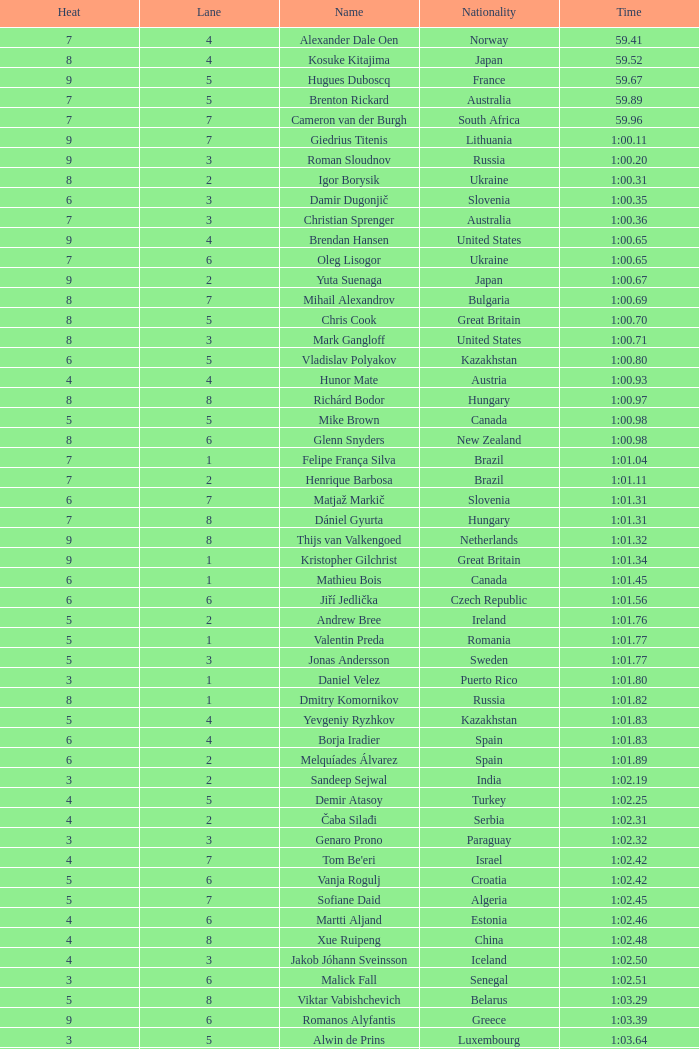What is the time in a heat smaller than 5, in Lane 5, for Vietnam? 1:06.36. Would you be able to parse every entry in this table? {'header': ['Heat', 'Lane', 'Name', 'Nationality', 'Time'], 'rows': [['7', '4', 'Alexander Dale Oen', 'Norway', '59.41'], ['8', '4', 'Kosuke Kitajima', 'Japan', '59.52'], ['9', '5', 'Hugues Duboscq', 'France', '59.67'], ['7', '5', 'Brenton Rickard', 'Australia', '59.89'], ['7', '7', 'Cameron van der Burgh', 'South Africa', '59.96'], ['9', '7', 'Giedrius Titenis', 'Lithuania', '1:00.11'], ['9', '3', 'Roman Sloudnov', 'Russia', '1:00.20'], ['8', '2', 'Igor Borysik', 'Ukraine', '1:00.31'], ['6', '3', 'Damir Dugonjič', 'Slovenia', '1:00.35'], ['7', '3', 'Christian Sprenger', 'Australia', '1:00.36'], ['9', '4', 'Brendan Hansen', 'United States', '1:00.65'], ['7', '6', 'Oleg Lisogor', 'Ukraine', '1:00.65'], ['9', '2', 'Yuta Suenaga', 'Japan', '1:00.67'], ['8', '7', 'Mihail Alexandrov', 'Bulgaria', '1:00.69'], ['8', '5', 'Chris Cook', 'Great Britain', '1:00.70'], ['8', '3', 'Mark Gangloff', 'United States', '1:00.71'], ['6', '5', 'Vladislav Polyakov', 'Kazakhstan', '1:00.80'], ['4', '4', 'Hunor Mate', 'Austria', '1:00.93'], ['8', '8', 'Richárd Bodor', 'Hungary', '1:00.97'], ['5', '5', 'Mike Brown', 'Canada', '1:00.98'], ['8', '6', 'Glenn Snyders', 'New Zealand', '1:00.98'], ['7', '1', 'Felipe França Silva', 'Brazil', '1:01.04'], ['7', '2', 'Henrique Barbosa', 'Brazil', '1:01.11'], ['6', '7', 'Matjaž Markič', 'Slovenia', '1:01.31'], ['7', '8', 'Dániel Gyurta', 'Hungary', '1:01.31'], ['9', '8', 'Thijs van Valkengoed', 'Netherlands', '1:01.32'], ['9', '1', 'Kristopher Gilchrist', 'Great Britain', '1:01.34'], ['6', '1', 'Mathieu Bois', 'Canada', '1:01.45'], ['6', '6', 'Jiří Jedlička', 'Czech Republic', '1:01.56'], ['5', '2', 'Andrew Bree', 'Ireland', '1:01.76'], ['5', '1', 'Valentin Preda', 'Romania', '1:01.77'], ['5', '3', 'Jonas Andersson', 'Sweden', '1:01.77'], ['3', '1', 'Daniel Velez', 'Puerto Rico', '1:01.80'], ['8', '1', 'Dmitry Komornikov', 'Russia', '1:01.82'], ['5', '4', 'Yevgeniy Ryzhkov', 'Kazakhstan', '1:01.83'], ['6', '4', 'Borja Iradier', 'Spain', '1:01.83'], ['6', '2', 'Melquíades Álvarez', 'Spain', '1:01.89'], ['3', '2', 'Sandeep Sejwal', 'India', '1:02.19'], ['4', '5', 'Demir Atasoy', 'Turkey', '1:02.25'], ['4', '2', 'Čaba Silađi', 'Serbia', '1:02.31'], ['3', '3', 'Genaro Prono', 'Paraguay', '1:02.32'], ['4', '7', "Tom Be'eri", 'Israel', '1:02.42'], ['5', '6', 'Vanja Rogulj', 'Croatia', '1:02.42'], ['5', '7', 'Sofiane Daid', 'Algeria', '1:02.45'], ['4', '6', 'Martti Aljand', 'Estonia', '1:02.46'], ['4', '8', 'Xue Ruipeng', 'China', '1:02.48'], ['4', '3', 'Jakob Jóhann Sveinsson', 'Iceland', '1:02.50'], ['3', '6', 'Malick Fall', 'Senegal', '1:02.51'], ['5', '8', 'Viktar Vabishchevich', 'Belarus', '1:03.29'], ['9', '6', 'Romanos Alyfantis', 'Greece', '1:03.39'], ['3', '5', 'Alwin de Prins', 'Luxembourg', '1:03.64'], ['3', '4', 'Sergio Andres Ferreyra', 'Argentina', '1:03.65'], ['2', '3', 'Edgar Crespo', 'Panama', '1:03.72'], ['2', '4', 'Sergiu Postica', 'Moldova', '1:03.83'], ['3', '8', 'Andrei Cross', 'Barbados', '1:04.57'], ['3', '7', 'Ivan Demyanenko', 'Uzbekistan', '1:05.14'], ['2', '6', 'Wael Koubrousli', 'Lebanon', '1:06.22'], ['2', '5', 'Nguyen Huu Viet', 'Vietnam', '1:06.36'], ['2', '2', 'Erik Rajohnson', 'Madagascar', '1:08.42'], ['2', '7', 'Boldbaataryn Bütekh-Uils', 'Mongolia', '1:10.80'], ['1', '4', 'Osama Mohammed Ye Alarag', 'Qatar', '1:10.83'], ['1', '5', 'Mohammed Al-Habsi', 'Oman', '1:12.28'], ['1', '3', 'Petero Okotai', 'Cook Islands', '1:20.20'], ['6', '8', 'Alessandro Terrin', 'Italy', 'DSQ'], ['4', '1', 'Mohammad Alirezaei', 'Iran', 'DNS']]} 